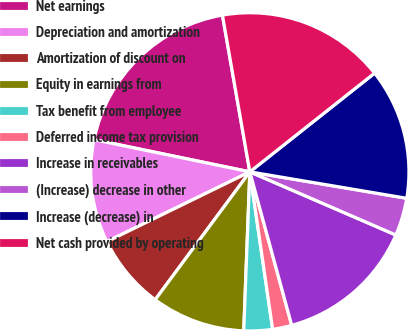Convert chart. <chart><loc_0><loc_0><loc_500><loc_500><pie_chart><fcel>Net earnings<fcel>Depreciation and amortization<fcel>Amortization of discount on<fcel>Equity in earnings from<fcel>Tax benefit from employee<fcel>Deferred income tax provision<fcel>Increase in receivables<fcel>(Increase) decrease in other<fcel>Increase (decrease) in<fcel>Net cash provided by operating<nl><fcel>19.0%<fcel>10.47%<fcel>7.63%<fcel>9.53%<fcel>2.9%<fcel>1.95%<fcel>14.26%<fcel>3.84%<fcel>13.31%<fcel>17.1%<nl></chart> 